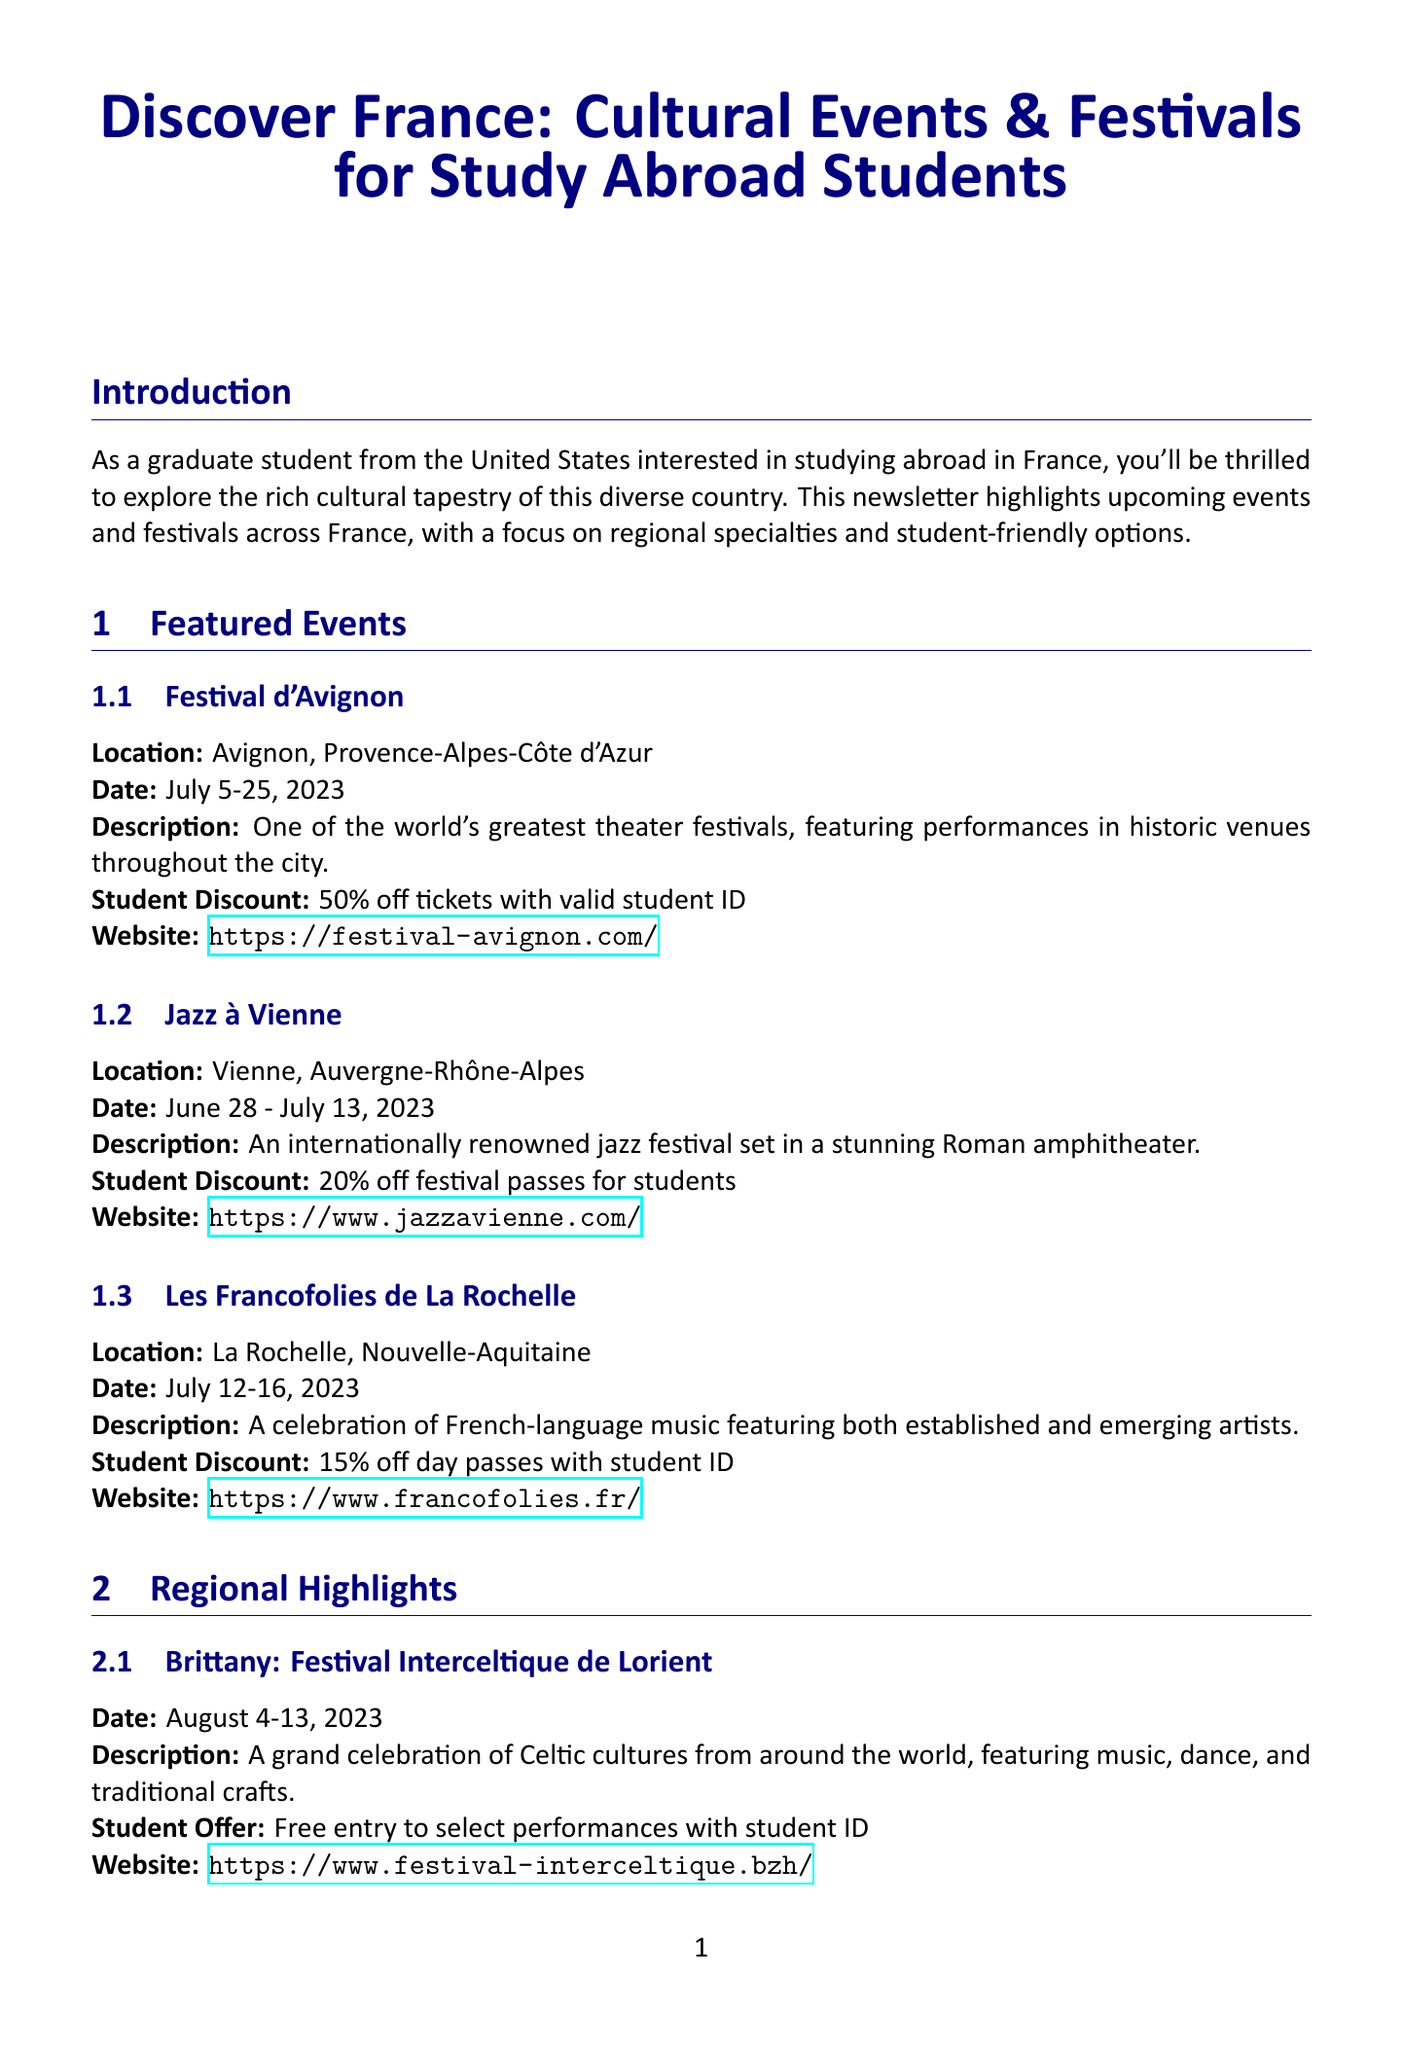What is the name of the festival in Avignon? The festival in Avignon is named Festival d'Avignon.
Answer: Festival d'Avignon What is the student discount for Jazz à Vienne? The student discount for Jazz à Vienne is 20% off festival passes for students.
Answer: 20% off festival passes for students When does the Festival Interceltique de Lorient take place? The Festival Interceltique de Lorient takes place from August 4-13, 2023.
Answer: August 4-13, 2023 What is the primary focus of the Strasbourg European Fantastic Film Festival? The primary focus of the Strasbourg European Fantastic Film Festival is on science fiction, fantasy, and horror genres.
Answer: Science fiction, fantasy, and horror genres How much is the student discount at Les Francofolies de La Rochelle? The student discount at Les Francofolies de La Rochelle is 15% off day passes with student ID.
Answer: 15% off day passes with student ID What type of cultural celebration is the Feria de Nîmes? The Feria de Nîmes is a vibrant festival celebrating bullfighting and Camargue culture.
Answer: Bullfighting and Camargue culture What organization can provide guidance on studying in France? Campus France USA is the organization that provides guidance on studying in France.
Answer: Campus France USA What is a benefit of participating in local festivals according to the cultural insight section? A benefit of participating in local festivals is to immerse yourself in French culture and practice your language skills.
Answer: Immerse yourself in French culture and practice your language skills 